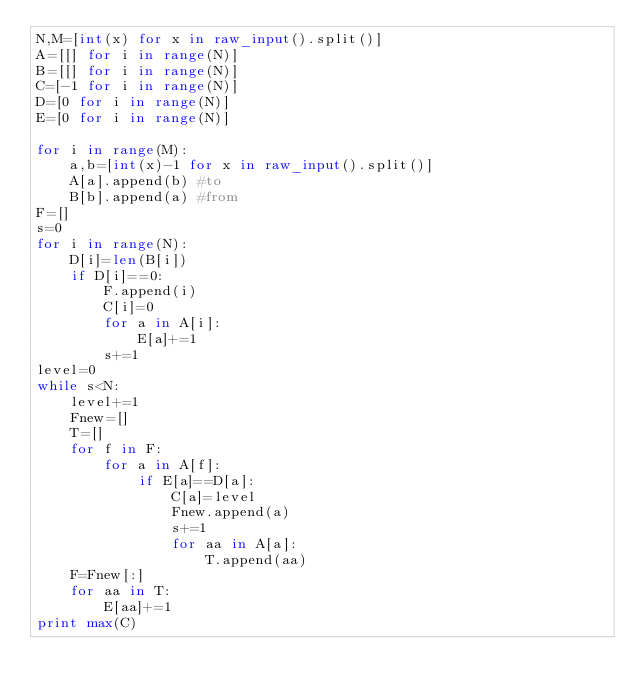<code> <loc_0><loc_0><loc_500><loc_500><_Python_>N,M=[int(x) for x in raw_input().split()]
A=[[] for i in range(N)]
B=[[] for i in range(N)]
C=[-1 for i in range(N)]
D=[0 for i in range(N)]
E=[0 for i in range(N)]

for i in range(M):
    a,b=[int(x)-1 for x in raw_input().split()]
    A[a].append(b) #to
    B[b].append(a) #from
F=[]
s=0
for i in range(N):
    D[i]=len(B[i])
    if D[i]==0:
        F.append(i)
        C[i]=0
        for a in A[i]:
            E[a]+=1
        s+=1
level=0
while s<N:
    level+=1
    Fnew=[]
    T=[]
    for f in F:
        for a in A[f]:
            if E[a]==D[a]:
                C[a]=level
                Fnew.append(a)
                s+=1
                for aa in A[a]:
                    T.append(aa)
    F=Fnew[:]
    for aa in T:
        E[aa]+=1
print max(C)
</code> 